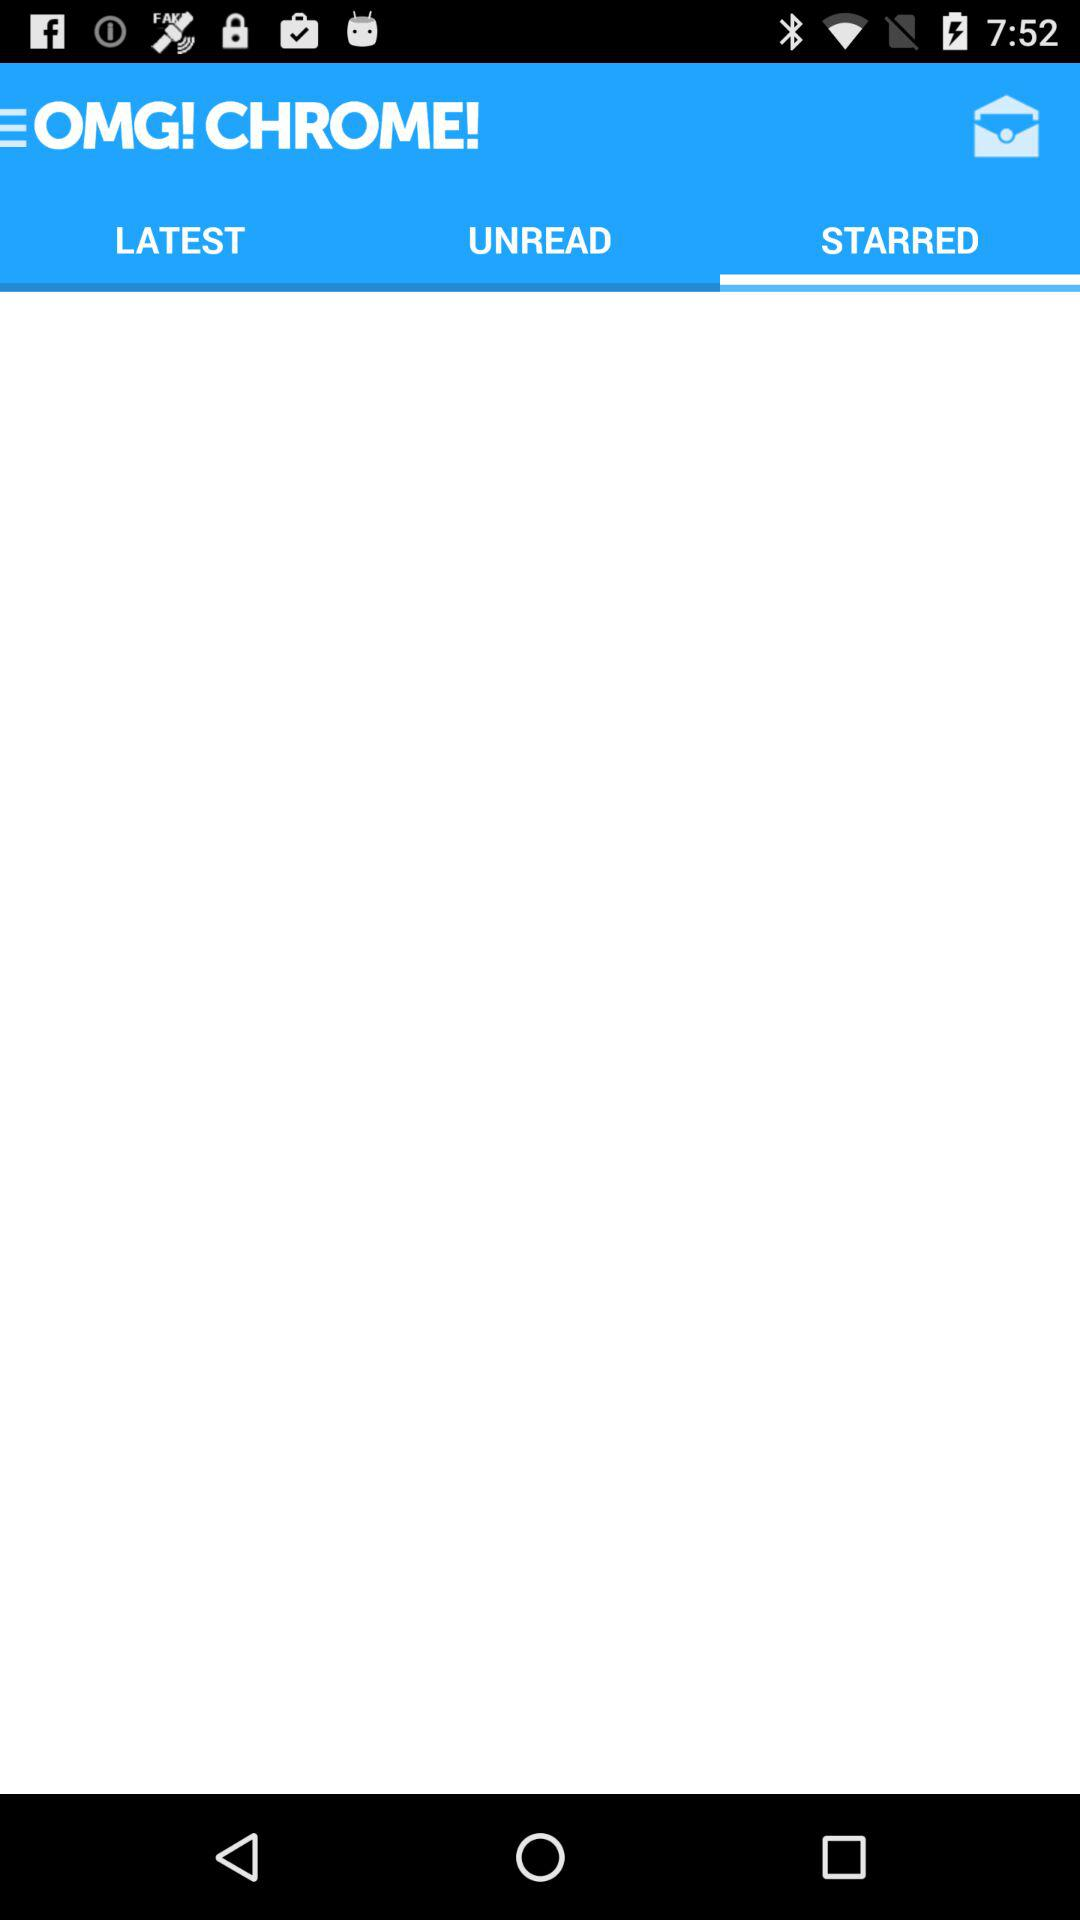Which tab has been selected? The selected tab is "STARRED". 